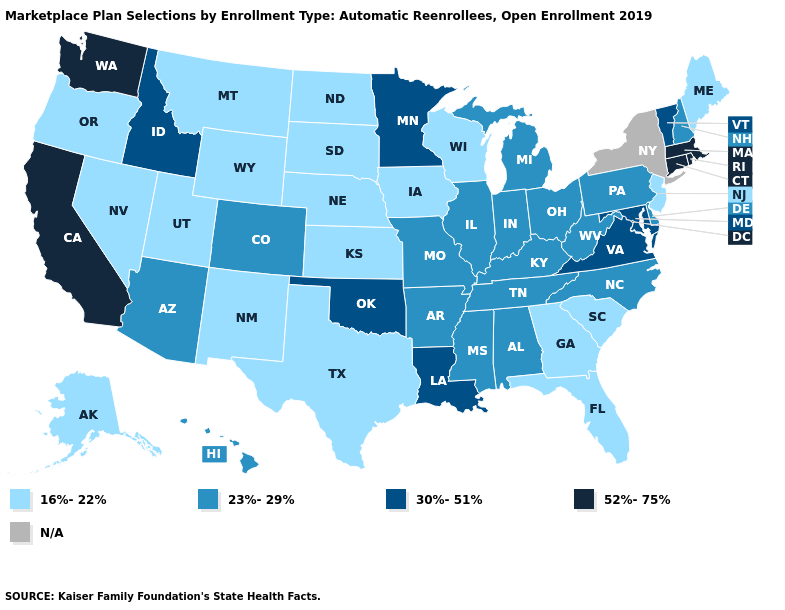Is the legend a continuous bar?
Quick response, please. No. Name the states that have a value in the range 30%-51%?
Keep it brief. Idaho, Louisiana, Maryland, Minnesota, Oklahoma, Vermont, Virginia. Name the states that have a value in the range 16%-22%?
Keep it brief. Alaska, Florida, Georgia, Iowa, Kansas, Maine, Montana, Nebraska, Nevada, New Jersey, New Mexico, North Dakota, Oregon, South Carolina, South Dakota, Texas, Utah, Wisconsin, Wyoming. Is the legend a continuous bar?
Be succinct. No. What is the value of Illinois?
Answer briefly. 23%-29%. Name the states that have a value in the range 52%-75%?
Short answer required. California, Connecticut, Massachusetts, Rhode Island, Washington. What is the highest value in the USA?
Keep it brief. 52%-75%. Which states have the lowest value in the USA?
Write a very short answer. Alaska, Florida, Georgia, Iowa, Kansas, Maine, Montana, Nebraska, Nevada, New Jersey, New Mexico, North Dakota, Oregon, South Carolina, South Dakota, Texas, Utah, Wisconsin, Wyoming. Does Washington have the highest value in the USA?
Short answer required. Yes. Among the states that border New Mexico , does Texas have the lowest value?
Give a very brief answer. Yes. Does the map have missing data?
Answer briefly. Yes. What is the value of Alaska?
Short answer required. 16%-22%. What is the value of Indiana?
Be succinct. 23%-29%. 